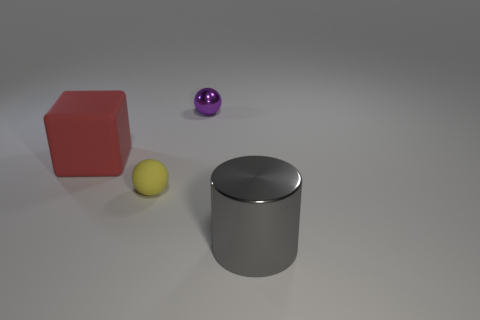Add 4 big gray objects. How many objects exist? 8 Subtract all cylinders. How many objects are left? 3 Add 1 yellow matte spheres. How many yellow matte spheres are left? 2 Add 1 small matte spheres. How many small matte spheres exist? 2 Subtract 0 cyan cylinders. How many objects are left? 4 Subtract all red things. Subtract all tiny purple things. How many objects are left? 2 